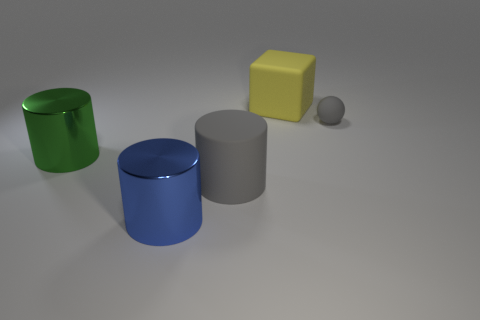What colors are the objects in the image, and which one appears to be closest to the foreground? The objects in the image encompass a variety of colors: there is a green cylinder, a blue cylinder, a gray cylinder, a yellow cube, and a small gray ball. The large blue cylinder appears to be closest to the foreground. 